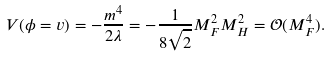Convert formula to latex. <formula><loc_0><loc_0><loc_500><loc_500>V ( \phi = v ) = - \frac { m ^ { 4 } } { 2 \lambda } = - \frac { 1 } { 8 \sqrt { 2 } } M _ { F } ^ { 2 } M _ { H } ^ { 2 } = \mathcal { O } ( M _ { F } ^ { 4 } ) .</formula> 